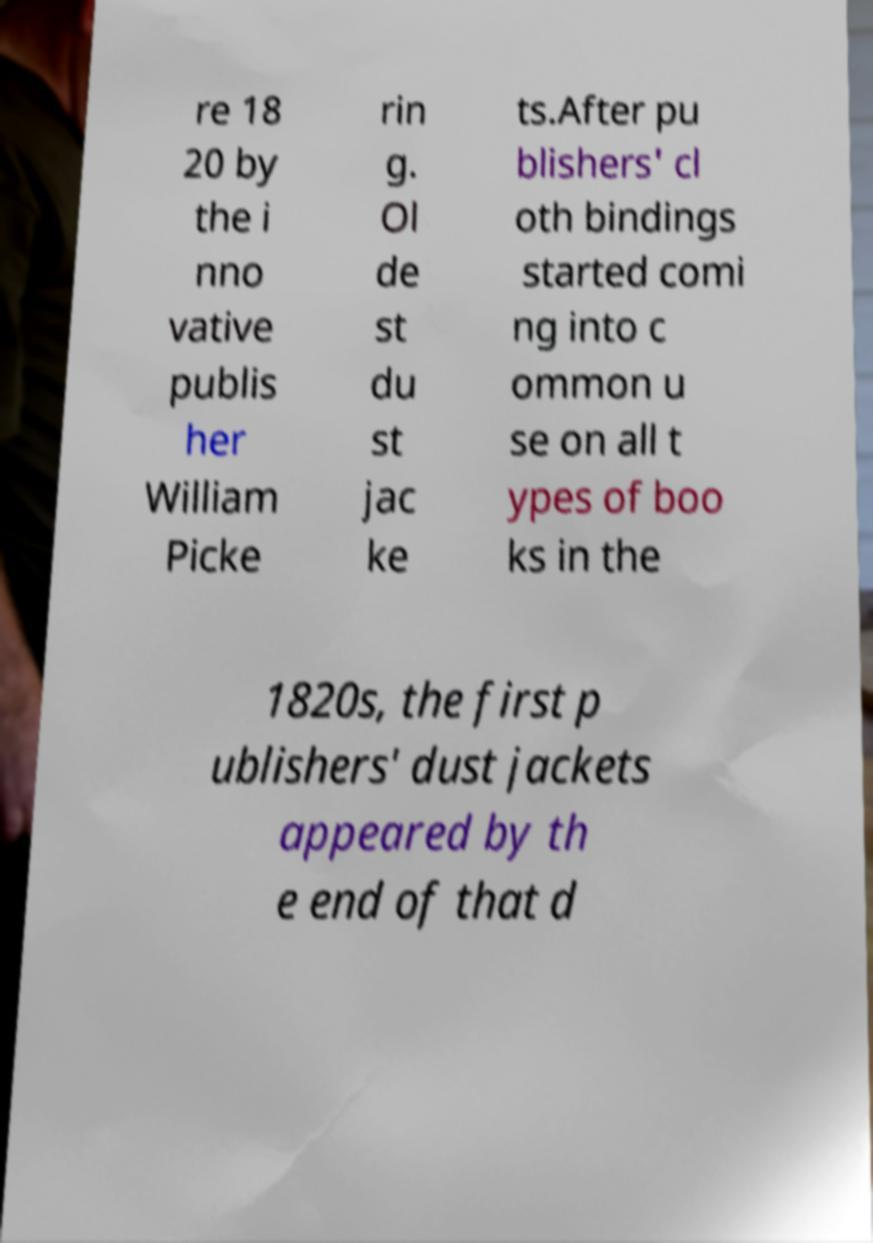Could you assist in decoding the text presented in this image and type it out clearly? re 18 20 by the i nno vative publis her William Picke rin g. Ol de st du st jac ke ts.After pu blishers' cl oth bindings started comi ng into c ommon u se on all t ypes of boo ks in the 1820s, the first p ublishers' dust jackets appeared by th e end of that d 